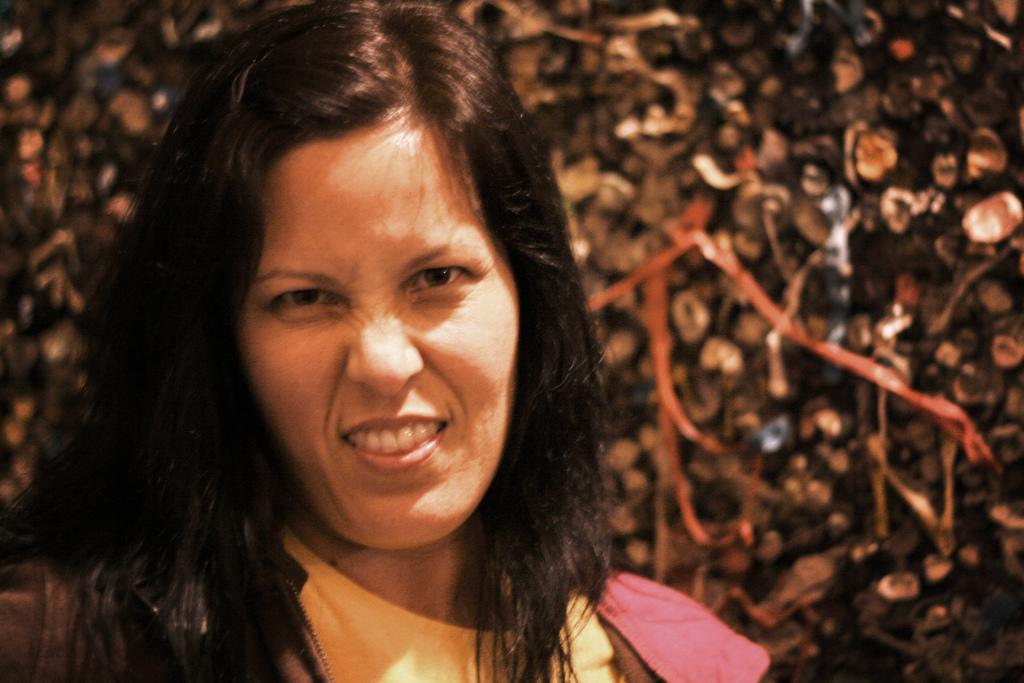Who is the main subject in the image? There is a woman in the image. Where is the woman located in relation to the image? The woman is in the foreground. What can be observed about the background of the image? The background of the woman is blurred. What color is the patch on the woman's shirt in the image? There is no patch visible on the woman's shirt in the image. How many oranges can be seen in the woman's hand in the image? There are no oranges present in the image. 